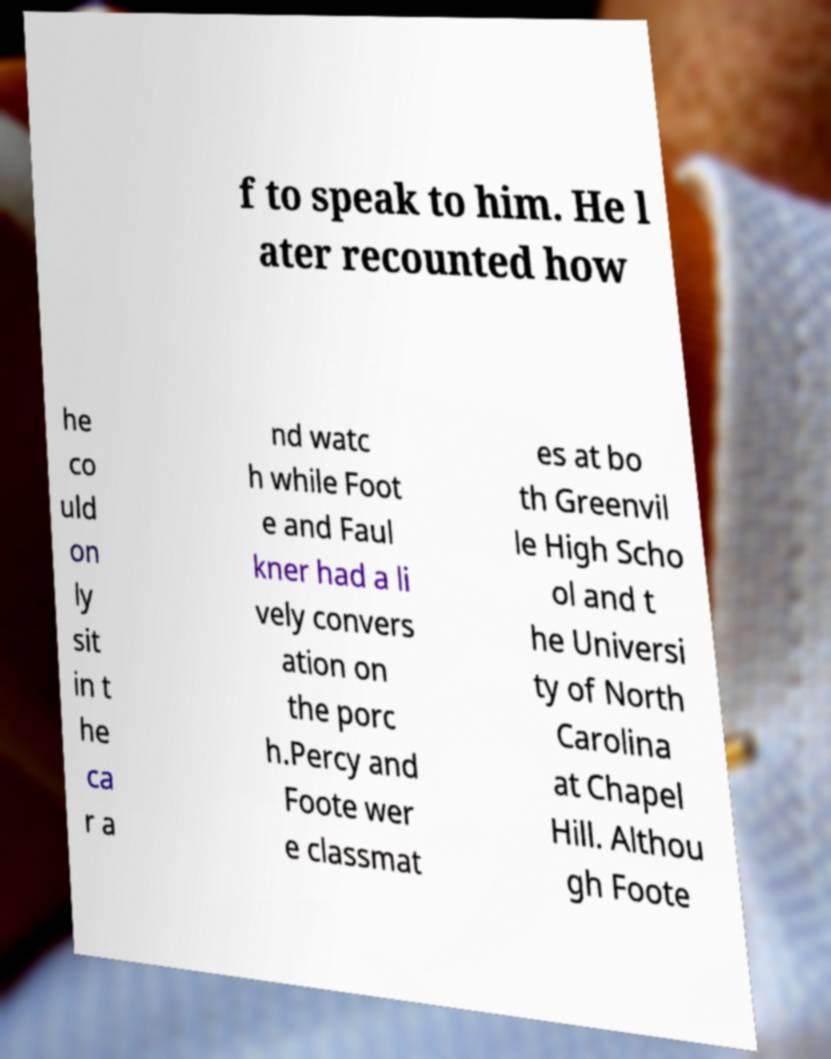Please identify and transcribe the text found in this image. f to speak to him. He l ater recounted how he co uld on ly sit in t he ca r a nd watc h while Foot e and Faul kner had a li vely convers ation on the porc h.Percy and Foote wer e classmat es at bo th Greenvil le High Scho ol and t he Universi ty of North Carolina at Chapel Hill. Althou gh Foote 